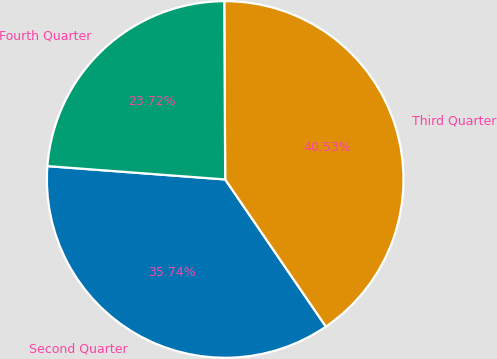<chart> <loc_0><loc_0><loc_500><loc_500><pie_chart><fcel>Second Quarter<fcel>Third Quarter<fcel>Fourth Quarter<nl><fcel>35.74%<fcel>40.53%<fcel>23.72%<nl></chart> 